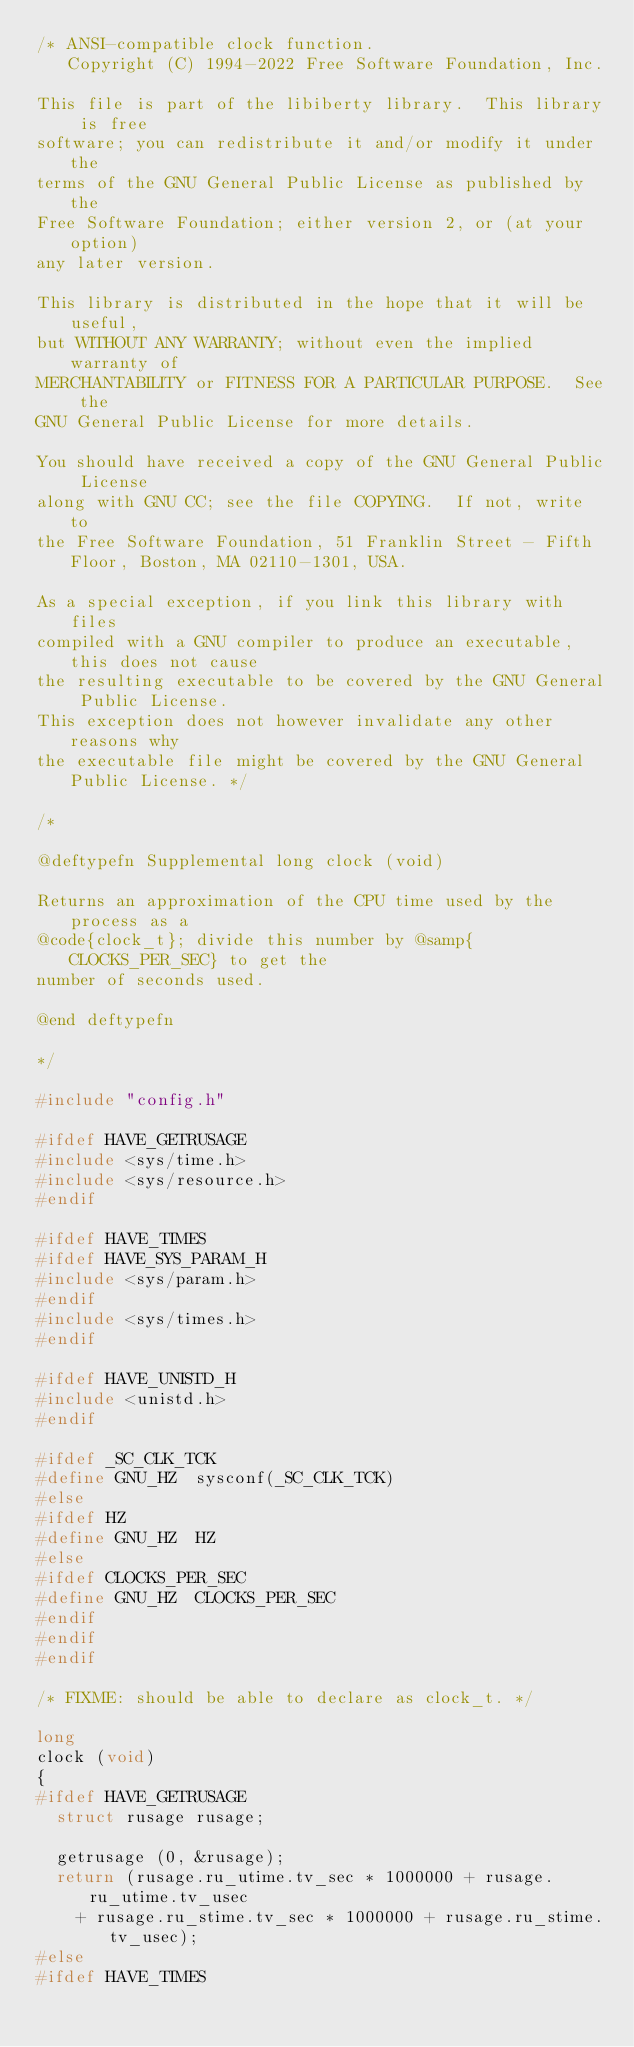Convert code to text. <code><loc_0><loc_0><loc_500><loc_500><_C_>/* ANSI-compatible clock function.
   Copyright (C) 1994-2022 Free Software Foundation, Inc.

This file is part of the libiberty library.  This library is free
software; you can redistribute it and/or modify it under the
terms of the GNU General Public License as published by the
Free Software Foundation; either version 2, or (at your option)
any later version.

This library is distributed in the hope that it will be useful,
but WITHOUT ANY WARRANTY; without even the implied warranty of
MERCHANTABILITY or FITNESS FOR A PARTICULAR PURPOSE.  See the
GNU General Public License for more details.

You should have received a copy of the GNU General Public License
along with GNU CC; see the file COPYING.  If not, write to
the Free Software Foundation, 51 Franklin Street - Fifth Floor, Boston, MA 02110-1301, USA.

As a special exception, if you link this library with files
compiled with a GNU compiler to produce an executable, this does not cause
the resulting executable to be covered by the GNU General Public License.
This exception does not however invalidate any other reasons why
the executable file might be covered by the GNU General Public License. */

/*

@deftypefn Supplemental long clock (void)

Returns an approximation of the CPU time used by the process as a
@code{clock_t}; divide this number by @samp{CLOCKS_PER_SEC} to get the
number of seconds used.

@end deftypefn

*/

#include "config.h"

#ifdef HAVE_GETRUSAGE
#include <sys/time.h>
#include <sys/resource.h>
#endif

#ifdef HAVE_TIMES
#ifdef HAVE_SYS_PARAM_H
#include <sys/param.h>
#endif
#include <sys/times.h>
#endif

#ifdef HAVE_UNISTD_H
#include <unistd.h>
#endif

#ifdef _SC_CLK_TCK
#define GNU_HZ  sysconf(_SC_CLK_TCK)
#else
#ifdef HZ
#define GNU_HZ  HZ
#else
#ifdef CLOCKS_PER_SEC
#define GNU_HZ  CLOCKS_PER_SEC
#endif
#endif
#endif

/* FIXME: should be able to declare as clock_t. */

long
clock (void)
{
#ifdef HAVE_GETRUSAGE
  struct rusage rusage;

  getrusage (0, &rusage);
  return (rusage.ru_utime.tv_sec * 1000000 + rusage.ru_utime.tv_usec
	  + rusage.ru_stime.tv_sec * 1000000 + rusage.ru_stime.tv_usec);
#else
#ifdef HAVE_TIMES</code> 